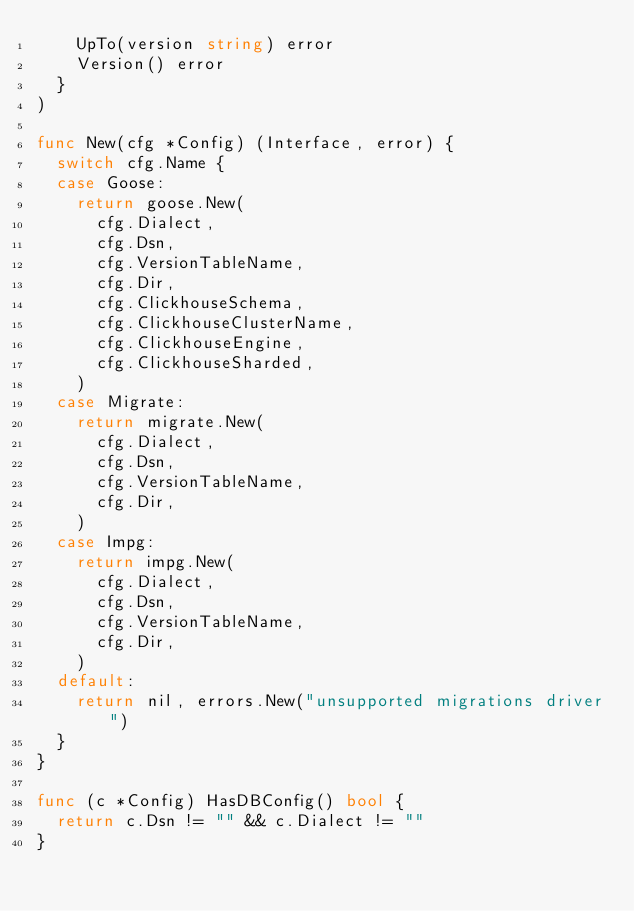<code> <loc_0><loc_0><loc_500><loc_500><_Go_>		UpTo(version string) error
		Version() error
	}
)

func New(cfg *Config) (Interface, error) {
	switch cfg.Name {
	case Goose:
		return goose.New(
			cfg.Dialect,
			cfg.Dsn,
			cfg.VersionTableName,
			cfg.Dir,
			cfg.ClickhouseSchema,
			cfg.ClickhouseClusterName,
			cfg.ClickhouseEngine,
			cfg.ClickhouseSharded,
		)
	case Migrate:
		return migrate.New(
			cfg.Dialect,
			cfg.Dsn,
			cfg.VersionTableName,
			cfg.Dir,
		)
	case Impg:
		return impg.New(
			cfg.Dialect,
			cfg.Dsn,
			cfg.VersionTableName,
			cfg.Dir,
		)
	default:
		return nil, errors.New("unsupported migrations driver")
	}
}

func (c *Config) HasDBConfig() bool {
	return c.Dsn != "" && c.Dialect != ""
}
</code> 